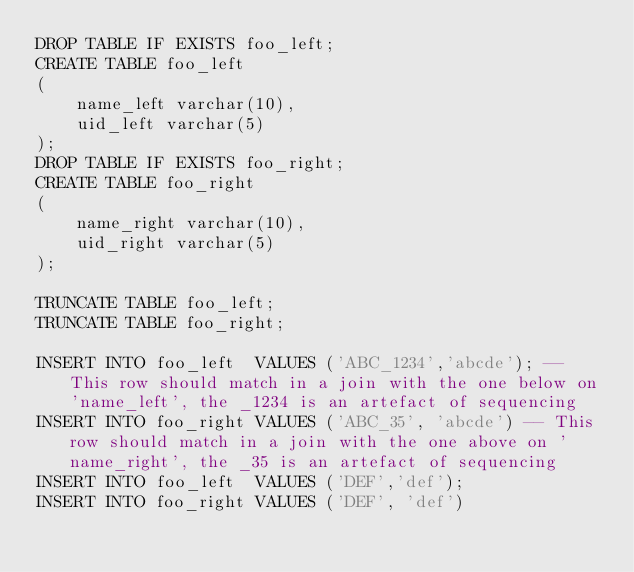<code> <loc_0><loc_0><loc_500><loc_500><_SQL_>DROP TABLE IF EXISTS foo_left;
CREATE TABLE foo_left
(
	name_left varchar(10),
	uid_left varchar(5)
);
DROP TABLE IF EXISTS foo_right;
CREATE TABLE foo_right
(
	name_right varchar(10),
	uid_right varchar(5)
);

TRUNCATE TABLE foo_left;
TRUNCATE TABLE foo_right;

INSERT INTO foo_left  VALUES ('ABC_1234','abcde'); -- This row should match in a join with the one below on 'name_left', the _1234 is an artefact of sequencing
INSERT INTO foo_right VALUES ('ABC_35', 'abcde') -- This row should match in a join with the one above on 'name_right', the _35 is an artefact of sequencing
INSERT INTO foo_left  VALUES ('DEF','def');
INSERT INTO foo_right VALUES ('DEF', 'def')
</code> 